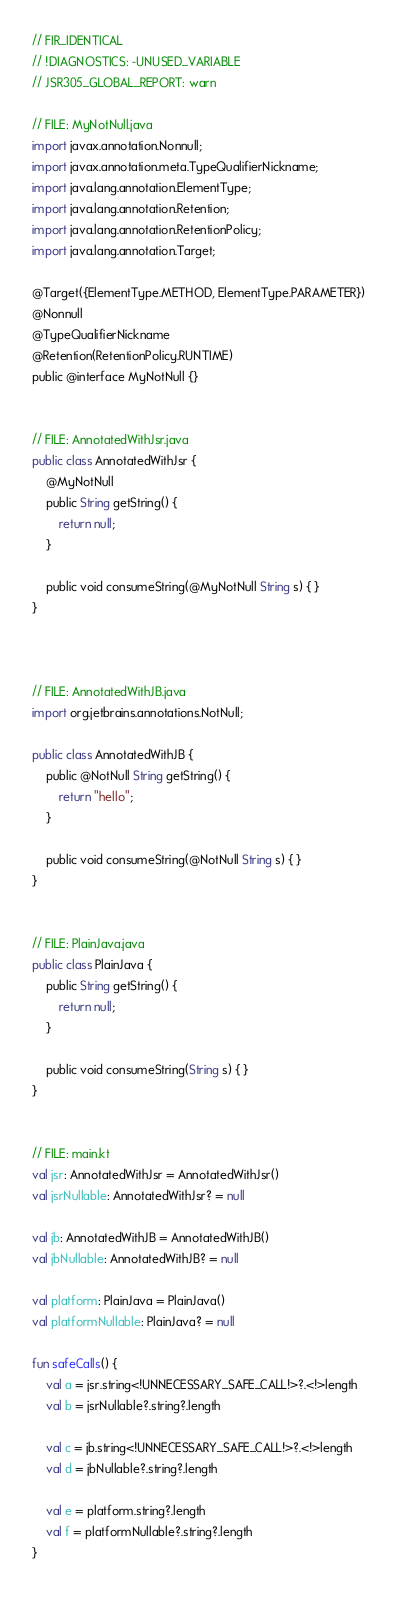Convert code to text. <code><loc_0><loc_0><loc_500><loc_500><_Kotlin_>// FIR_IDENTICAL
// !DIAGNOSTICS: -UNUSED_VARIABLE
// JSR305_GLOBAL_REPORT: warn

// FILE: MyNotNull.java
import javax.annotation.Nonnull;
import javax.annotation.meta.TypeQualifierNickname;
import java.lang.annotation.ElementType;
import java.lang.annotation.Retention;
import java.lang.annotation.RetentionPolicy;
import java.lang.annotation.Target;

@Target({ElementType.METHOD, ElementType.PARAMETER})
@Nonnull
@TypeQualifierNickname
@Retention(RetentionPolicy.RUNTIME)
public @interface MyNotNull {}


// FILE: AnnotatedWithJsr.java
public class AnnotatedWithJsr {
    @MyNotNull
    public String getString() {
        return null;
    }

    public void consumeString(@MyNotNull String s) { }
}



// FILE: AnnotatedWithJB.java
import org.jetbrains.annotations.NotNull;

public class AnnotatedWithJB {
    public @NotNull String getString() {
        return "hello";
    }

    public void consumeString(@NotNull String s) { }
}


// FILE: PlainJava.java
public class PlainJava {
    public String getString() {
        return null;
    }

    public void consumeString(String s) { }
}


// FILE: main.kt
val jsr: AnnotatedWithJsr = AnnotatedWithJsr()
val jsrNullable: AnnotatedWithJsr? = null

val jb: AnnotatedWithJB = AnnotatedWithJB()
val jbNullable: AnnotatedWithJB? = null

val platform: PlainJava = PlainJava()
val platformNullable: PlainJava? = null

fun safeCalls() {
    val a = jsr.string<!UNNECESSARY_SAFE_CALL!>?.<!>length
    val b = jsrNullable?.string?.length

    val c = jb.string<!UNNECESSARY_SAFE_CALL!>?.<!>length
    val d = jbNullable?.string?.length

    val e = platform.string?.length
    val f = platformNullable?.string?.length
}
</code> 